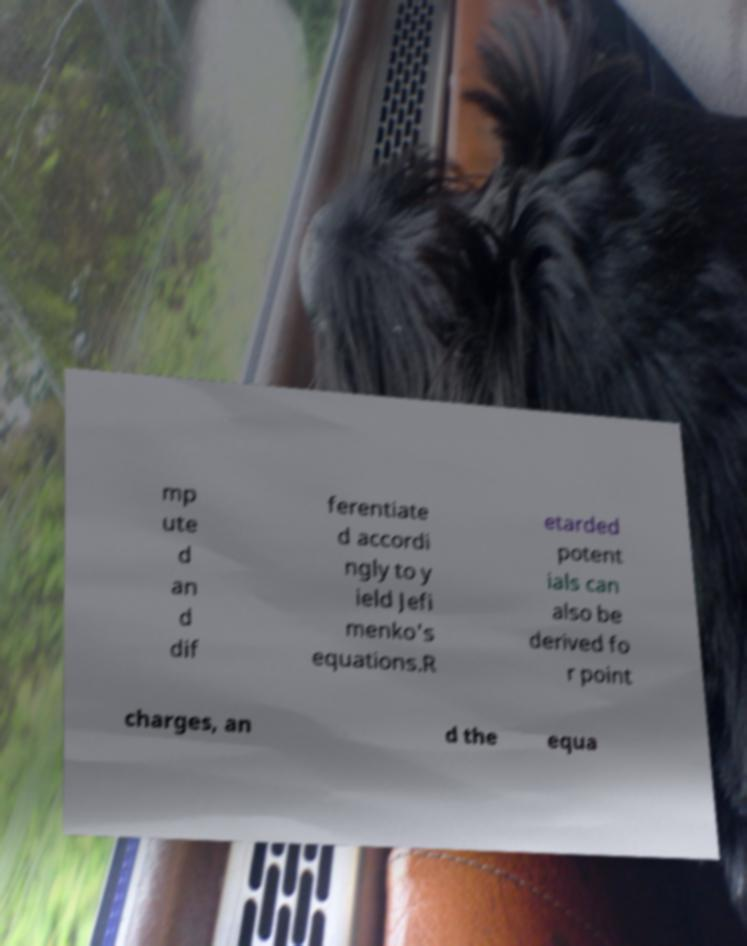For documentation purposes, I need the text within this image transcribed. Could you provide that? mp ute d an d dif ferentiate d accordi ngly to y ield Jefi menko's equations.R etarded potent ials can also be derived fo r point charges, an d the equa 